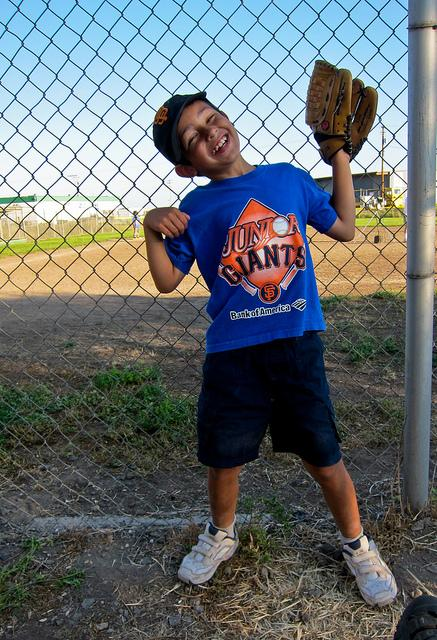What is on the boy's hand? glove 